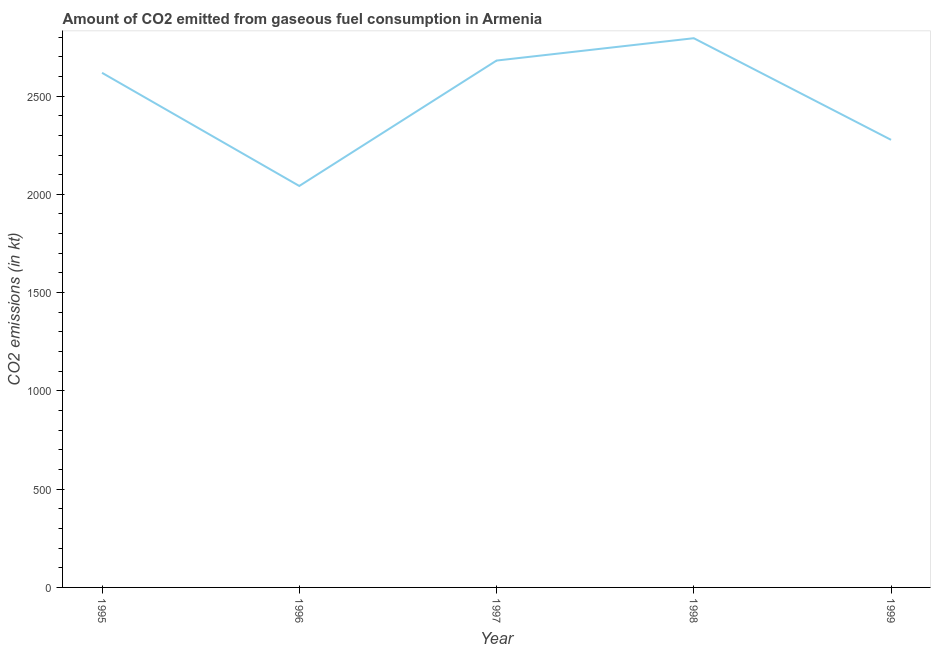What is the co2 emissions from gaseous fuel consumption in 1995?
Provide a short and direct response. 2618.24. Across all years, what is the maximum co2 emissions from gaseous fuel consumption?
Keep it short and to the point. 2794.25. Across all years, what is the minimum co2 emissions from gaseous fuel consumption?
Keep it short and to the point. 2042.52. In which year was the co2 emissions from gaseous fuel consumption maximum?
Keep it short and to the point. 1998. In which year was the co2 emissions from gaseous fuel consumption minimum?
Your response must be concise. 1996. What is the sum of the co2 emissions from gaseous fuel consumption?
Provide a short and direct response. 1.24e+04. What is the difference between the co2 emissions from gaseous fuel consumption in 1996 and 1998?
Provide a short and direct response. -751.74. What is the average co2 emissions from gaseous fuel consumption per year?
Your answer should be compact. 2482.56. What is the median co2 emissions from gaseous fuel consumption?
Your answer should be compact. 2618.24. In how many years, is the co2 emissions from gaseous fuel consumption greater than 1400 kt?
Provide a succinct answer. 5. Do a majority of the years between 1999 and 1997 (inclusive) have co2 emissions from gaseous fuel consumption greater than 1100 kt?
Offer a very short reply. No. What is the ratio of the co2 emissions from gaseous fuel consumption in 1995 to that in 1999?
Your answer should be very brief. 1.15. What is the difference between the highest and the second highest co2 emissions from gaseous fuel consumption?
Ensure brevity in your answer.  113.68. What is the difference between the highest and the lowest co2 emissions from gaseous fuel consumption?
Your answer should be compact. 751.74. In how many years, is the co2 emissions from gaseous fuel consumption greater than the average co2 emissions from gaseous fuel consumption taken over all years?
Make the answer very short. 3. Does the co2 emissions from gaseous fuel consumption monotonically increase over the years?
Your response must be concise. No. How many lines are there?
Offer a very short reply. 1. How many years are there in the graph?
Provide a succinct answer. 5. Does the graph contain any zero values?
Keep it short and to the point. No. Does the graph contain grids?
Your response must be concise. No. What is the title of the graph?
Your answer should be very brief. Amount of CO2 emitted from gaseous fuel consumption in Armenia. What is the label or title of the Y-axis?
Provide a short and direct response. CO2 emissions (in kt). What is the CO2 emissions (in kt) of 1995?
Your answer should be compact. 2618.24. What is the CO2 emissions (in kt) in 1996?
Your answer should be compact. 2042.52. What is the CO2 emissions (in kt) in 1997?
Your answer should be very brief. 2680.58. What is the CO2 emissions (in kt) of 1998?
Your response must be concise. 2794.25. What is the CO2 emissions (in kt) in 1999?
Make the answer very short. 2277.21. What is the difference between the CO2 emissions (in kt) in 1995 and 1996?
Provide a short and direct response. 575.72. What is the difference between the CO2 emissions (in kt) in 1995 and 1997?
Make the answer very short. -62.34. What is the difference between the CO2 emissions (in kt) in 1995 and 1998?
Offer a terse response. -176.02. What is the difference between the CO2 emissions (in kt) in 1995 and 1999?
Offer a terse response. 341.03. What is the difference between the CO2 emissions (in kt) in 1996 and 1997?
Provide a short and direct response. -638.06. What is the difference between the CO2 emissions (in kt) in 1996 and 1998?
Provide a succinct answer. -751.74. What is the difference between the CO2 emissions (in kt) in 1996 and 1999?
Keep it short and to the point. -234.69. What is the difference between the CO2 emissions (in kt) in 1997 and 1998?
Offer a terse response. -113.68. What is the difference between the CO2 emissions (in kt) in 1997 and 1999?
Your answer should be compact. 403.37. What is the difference between the CO2 emissions (in kt) in 1998 and 1999?
Provide a short and direct response. 517.05. What is the ratio of the CO2 emissions (in kt) in 1995 to that in 1996?
Provide a succinct answer. 1.28. What is the ratio of the CO2 emissions (in kt) in 1995 to that in 1997?
Provide a succinct answer. 0.98. What is the ratio of the CO2 emissions (in kt) in 1995 to that in 1998?
Keep it short and to the point. 0.94. What is the ratio of the CO2 emissions (in kt) in 1995 to that in 1999?
Provide a short and direct response. 1.15. What is the ratio of the CO2 emissions (in kt) in 1996 to that in 1997?
Offer a very short reply. 0.76. What is the ratio of the CO2 emissions (in kt) in 1996 to that in 1998?
Give a very brief answer. 0.73. What is the ratio of the CO2 emissions (in kt) in 1996 to that in 1999?
Give a very brief answer. 0.9. What is the ratio of the CO2 emissions (in kt) in 1997 to that in 1998?
Your answer should be compact. 0.96. What is the ratio of the CO2 emissions (in kt) in 1997 to that in 1999?
Offer a terse response. 1.18. What is the ratio of the CO2 emissions (in kt) in 1998 to that in 1999?
Keep it short and to the point. 1.23. 